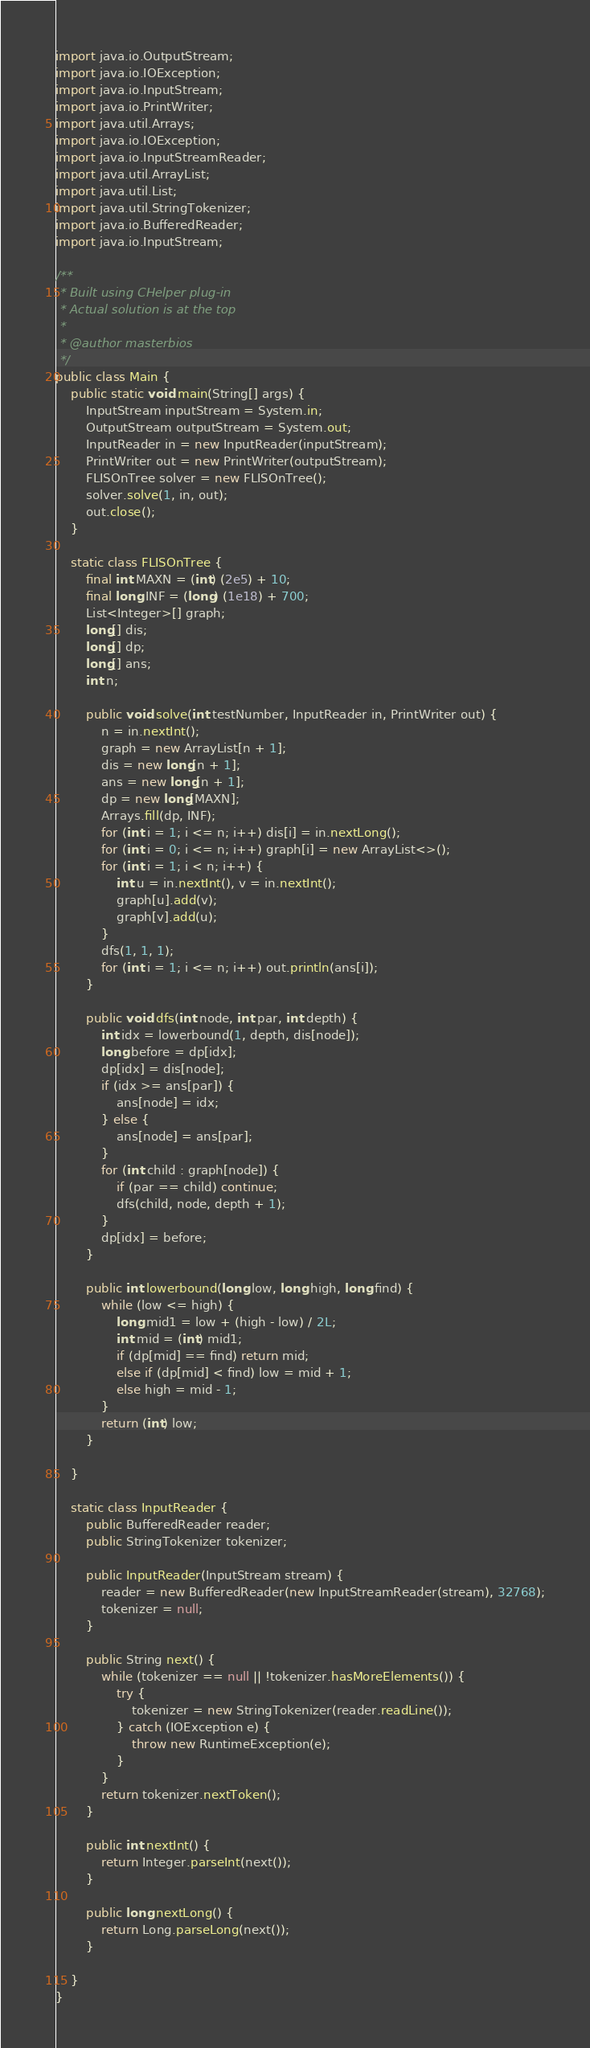Convert code to text. <code><loc_0><loc_0><loc_500><loc_500><_Java_>import java.io.OutputStream;
import java.io.IOException;
import java.io.InputStream;
import java.io.PrintWriter;
import java.util.Arrays;
import java.io.IOException;
import java.io.InputStreamReader;
import java.util.ArrayList;
import java.util.List;
import java.util.StringTokenizer;
import java.io.BufferedReader;
import java.io.InputStream;

/**
 * Built using CHelper plug-in
 * Actual solution is at the top
 *
 * @author masterbios
 */
public class Main {
    public static void main(String[] args) {
        InputStream inputStream = System.in;
        OutputStream outputStream = System.out;
        InputReader in = new InputReader(inputStream);
        PrintWriter out = new PrintWriter(outputStream);
        FLISOnTree solver = new FLISOnTree();
        solver.solve(1, in, out);
        out.close();
    }

    static class FLISOnTree {
        final int MAXN = (int) (2e5) + 10;
        final long INF = (long) (1e18) + 700;
        List<Integer>[] graph;
        long[] dis;
        long[] dp;
        long[] ans;
        int n;

        public void solve(int testNumber, InputReader in, PrintWriter out) {
            n = in.nextInt();
            graph = new ArrayList[n + 1];
            dis = new long[n + 1];
            ans = new long[n + 1];
            dp = new long[MAXN];
            Arrays.fill(dp, INF);
            for (int i = 1; i <= n; i++) dis[i] = in.nextLong();
            for (int i = 0; i <= n; i++) graph[i] = new ArrayList<>();
            for (int i = 1; i < n; i++) {
                int u = in.nextInt(), v = in.nextInt();
                graph[u].add(v);
                graph[v].add(u);
            }
            dfs(1, 1, 1);
            for (int i = 1; i <= n; i++) out.println(ans[i]);
        }

        public void dfs(int node, int par, int depth) {
            int idx = lowerbound(1, depth, dis[node]);
            long before = dp[idx];
            dp[idx] = dis[node];
            if (idx >= ans[par]) {
                ans[node] = idx;
            } else {
                ans[node] = ans[par];
            }
            for (int child : graph[node]) {
                if (par == child) continue;
                dfs(child, node, depth + 1);
            }
            dp[idx] = before;
        }

        public int lowerbound(long low, long high, long find) {
            while (low <= high) {
                long mid1 = low + (high - low) / 2L;
                int mid = (int) mid1;
                if (dp[mid] == find) return mid;
                else if (dp[mid] < find) low = mid + 1;
                else high = mid - 1;
            }
            return (int) low;
        }

    }

    static class InputReader {
        public BufferedReader reader;
        public StringTokenizer tokenizer;

        public InputReader(InputStream stream) {
            reader = new BufferedReader(new InputStreamReader(stream), 32768);
            tokenizer = null;
        }

        public String next() {
            while (tokenizer == null || !tokenizer.hasMoreElements()) {
                try {
                    tokenizer = new StringTokenizer(reader.readLine());
                } catch (IOException e) {
                    throw new RuntimeException(e);
                }
            }
            return tokenizer.nextToken();
        }

        public int nextInt() {
            return Integer.parseInt(next());
        }

        public long nextLong() {
            return Long.parseLong(next());
        }

    }
}

</code> 